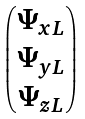Convert formula to latex. <formula><loc_0><loc_0><loc_500><loc_500>\begin{pmatrix} \Psi _ { x L } \\ \Psi _ { y L } \\ \Psi _ { z L } \end{pmatrix}</formula> 